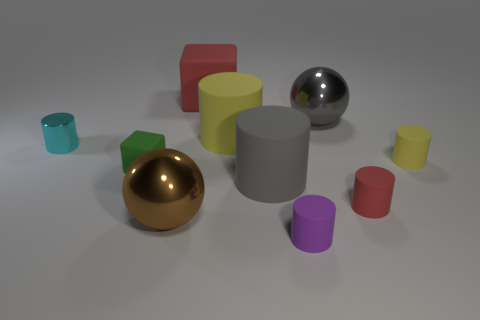Subtract all red cylinders. How many cylinders are left? 5 Subtract all big yellow cylinders. How many cylinders are left? 5 Subtract all cyan cylinders. Subtract all green balls. How many cylinders are left? 5 Subtract all spheres. How many objects are left? 8 Add 3 large brown things. How many large brown things exist? 4 Subtract 1 gray cylinders. How many objects are left? 9 Subtract all tiny purple things. Subtract all brown metallic spheres. How many objects are left? 8 Add 3 small yellow things. How many small yellow things are left? 4 